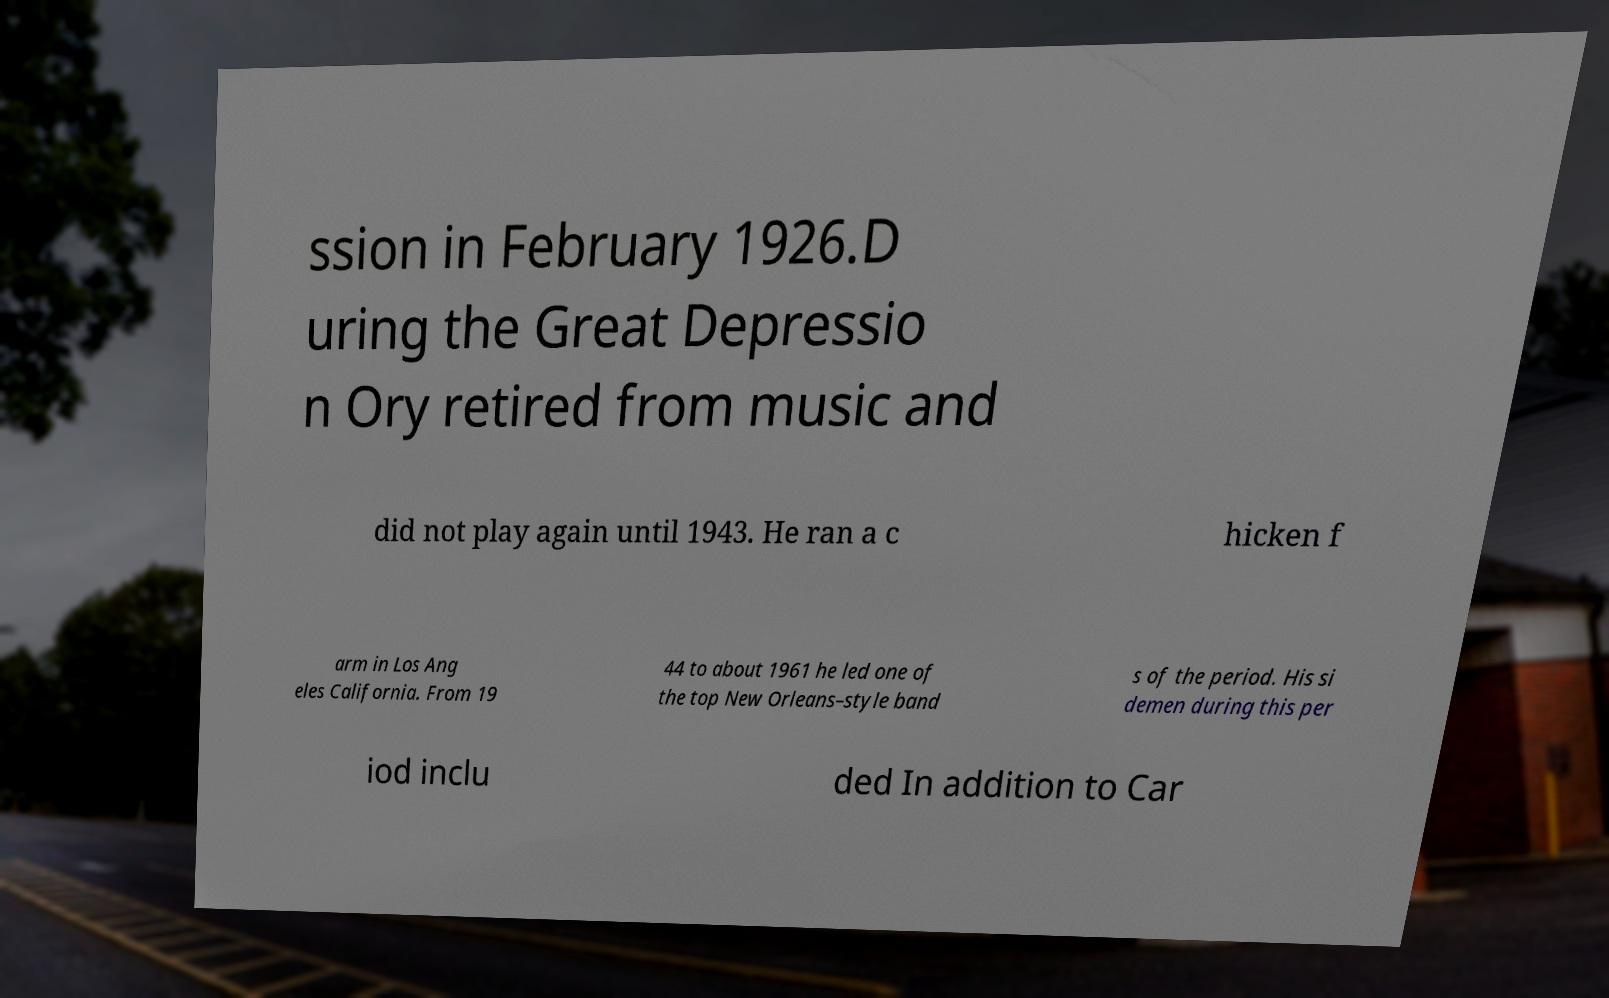Can you read and provide the text displayed in the image?This photo seems to have some interesting text. Can you extract and type it out for me? ssion in February 1926.D uring the Great Depressio n Ory retired from music and did not play again until 1943. He ran a c hicken f arm in Los Ang eles California. From 19 44 to about 1961 he led one of the top New Orleans–style band s of the period. His si demen during this per iod inclu ded In addition to Car 